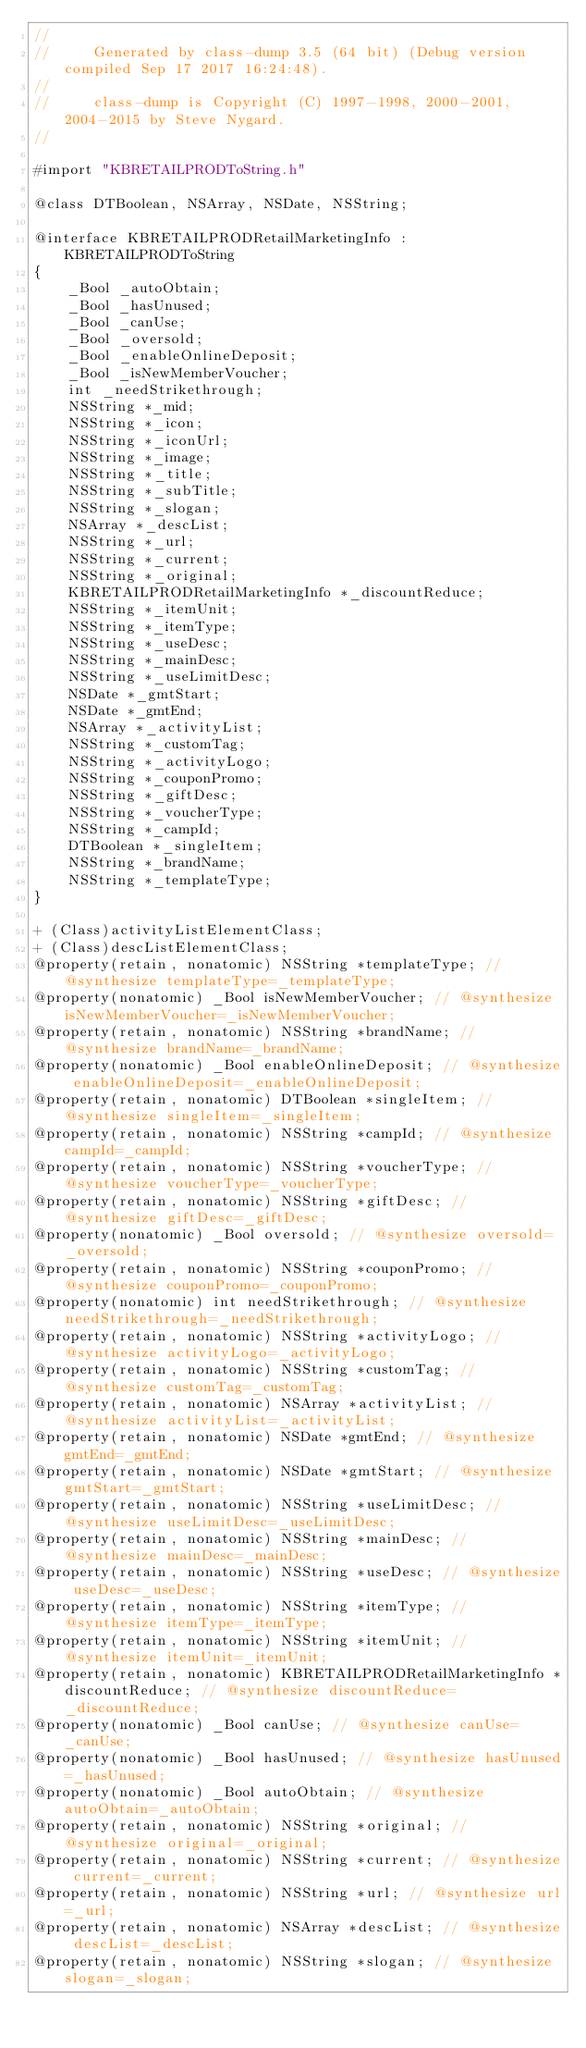<code> <loc_0><loc_0><loc_500><loc_500><_C_>//
//     Generated by class-dump 3.5 (64 bit) (Debug version compiled Sep 17 2017 16:24:48).
//
//     class-dump is Copyright (C) 1997-1998, 2000-2001, 2004-2015 by Steve Nygard.
//

#import "KBRETAILPRODToString.h"

@class DTBoolean, NSArray, NSDate, NSString;

@interface KBRETAILPRODRetailMarketingInfo : KBRETAILPRODToString
{
    _Bool _autoObtain;
    _Bool _hasUnused;
    _Bool _canUse;
    _Bool _oversold;
    _Bool _enableOnlineDeposit;
    _Bool _isNewMemberVoucher;
    int _needStrikethrough;
    NSString *_mid;
    NSString *_icon;
    NSString *_iconUrl;
    NSString *_image;
    NSString *_title;
    NSString *_subTitle;
    NSString *_slogan;
    NSArray *_descList;
    NSString *_url;
    NSString *_current;
    NSString *_original;
    KBRETAILPRODRetailMarketingInfo *_discountReduce;
    NSString *_itemUnit;
    NSString *_itemType;
    NSString *_useDesc;
    NSString *_mainDesc;
    NSString *_useLimitDesc;
    NSDate *_gmtStart;
    NSDate *_gmtEnd;
    NSArray *_activityList;
    NSString *_customTag;
    NSString *_activityLogo;
    NSString *_couponPromo;
    NSString *_giftDesc;
    NSString *_voucherType;
    NSString *_campId;
    DTBoolean *_singleItem;
    NSString *_brandName;
    NSString *_templateType;
}

+ (Class)activityListElementClass;
+ (Class)descListElementClass;
@property(retain, nonatomic) NSString *templateType; // @synthesize templateType=_templateType;
@property(nonatomic) _Bool isNewMemberVoucher; // @synthesize isNewMemberVoucher=_isNewMemberVoucher;
@property(retain, nonatomic) NSString *brandName; // @synthesize brandName=_brandName;
@property(nonatomic) _Bool enableOnlineDeposit; // @synthesize enableOnlineDeposit=_enableOnlineDeposit;
@property(retain, nonatomic) DTBoolean *singleItem; // @synthesize singleItem=_singleItem;
@property(retain, nonatomic) NSString *campId; // @synthesize campId=_campId;
@property(retain, nonatomic) NSString *voucherType; // @synthesize voucherType=_voucherType;
@property(retain, nonatomic) NSString *giftDesc; // @synthesize giftDesc=_giftDesc;
@property(nonatomic) _Bool oversold; // @synthesize oversold=_oversold;
@property(retain, nonatomic) NSString *couponPromo; // @synthesize couponPromo=_couponPromo;
@property(nonatomic) int needStrikethrough; // @synthesize needStrikethrough=_needStrikethrough;
@property(retain, nonatomic) NSString *activityLogo; // @synthesize activityLogo=_activityLogo;
@property(retain, nonatomic) NSString *customTag; // @synthesize customTag=_customTag;
@property(retain, nonatomic) NSArray *activityList; // @synthesize activityList=_activityList;
@property(retain, nonatomic) NSDate *gmtEnd; // @synthesize gmtEnd=_gmtEnd;
@property(retain, nonatomic) NSDate *gmtStart; // @synthesize gmtStart=_gmtStart;
@property(retain, nonatomic) NSString *useLimitDesc; // @synthesize useLimitDesc=_useLimitDesc;
@property(retain, nonatomic) NSString *mainDesc; // @synthesize mainDesc=_mainDesc;
@property(retain, nonatomic) NSString *useDesc; // @synthesize useDesc=_useDesc;
@property(retain, nonatomic) NSString *itemType; // @synthesize itemType=_itemType;
@property(retain, nonatomic) NSString *itemUnit; // @synthesize itemUnit=_itemUnit;
@property(retain, nonatomic) KBRETAILPRODRetailMarketingInfo *discountReduce; // @synthesize discountReduce=_discountReduce;
@property(nonatomic) _Bool canUse; // @synthesize canUse=_canUse;
@property(nonatomic) _Bool hasUnused; // @synthesize hasUnused=_hasUnused;
@property(nonatomic) _Bool autoObtain; // @synthesize autoObtain=_autoObtain;
@property(retain, nonatomic) NSString *original; // @synthesize original=_original;
@property(retain, nonatomic) NSString *current; // @synthesize current=_current;
@property(retain, nonatomic) NSString *url; // @synthesize url=_url;
@property(retain, nonatomic) NSArray *descList; // @synthesize descList=_descList;
@property(retain, nonatomic) NSString *slogan; // @synthesize slogan=_slogan;</code> 